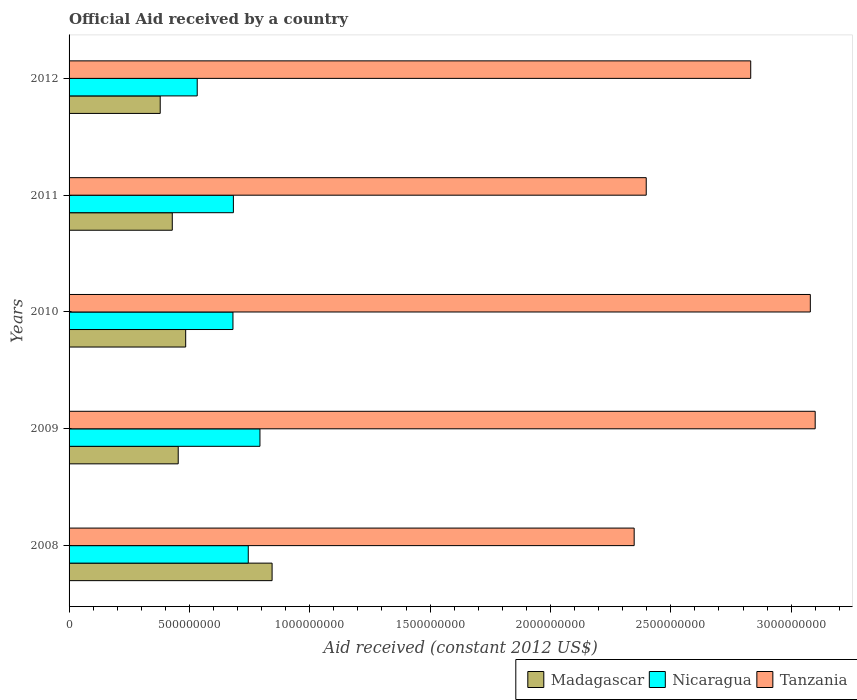How many groups of bars are there?
Your answer should be very brief. 5. Are the number of bars per tick equal to the number of legend labels?
Ensure brevity in your answer.  Yes. In how many cases, is the number of bars for a given year not equal to the number of legend labels?
Ensure brevity in your answer.  0. What is the net official aid received in Nicaragua in 2008?
Offer a very short reply. 7.44e+08. Across all years, what is the maximum net official aid received in Tanzania?
Make the answer very short. 3.10e+09. Across all years, what is the minimum net official aid received in Nicaragua?
Ensure brevity in your answer.  5.32e+08. In which year was the net official aid received in Madagascar minimum?
Keep it short and to the point. 2012. What is the total net official aid received in Madagascar in the graph?
Your answer should be very brief. 2.59e+09. What is the difference between the net official aid received in Tanzania in 2008 and that in 2010?
Give a very brief answer. -7.32e+08. What is the difference between the net official aid received in Nicaragua in 2009 and the net official aid received in Tanzania in 2012?
Ensure brevity in your answer.  -2.04e+09. What is the average net official aid received in Madagascar per year?
Your answer should be very brief. 5.18e+08. In the year 2011, what is the difference between the net official aid received in Madagascar and net official aid received in Tanzania?
Offer a very short reply. -1.97e+09. In how many years, is the net official aid received in Tanzania greater than 1000000000 US$?
Offer a very short reply. 5. What is the ratio of the net official aid received in Tanzania in 2009 to that in 2010?
Keep it short and to the point. 1.01. Is the difference between the net official aid received in Madagascar in 2008 and 2010 greater than the difference between the net official aid received in Tanzania in 2008 and 2010?
Ensure brevity in your answer.  Yes. What is the difference between the highest and the second highest net official aid received in Tanzania?
Give a very brief answer. 2.02e+07. What is the difference between the highest and the lowest net official aid received in Nicaragua?
Your response must be concise. 2.61e+08. What does the 1st bar from the top in 2009 represents?
Make the answer very short. Tanzania. What does the 3rd bar from the bottom in 2011 represents?
Ensure brevity in your answer.  Tanzania. Are all the bars in the graph horizontal?
Offer a terse response. Yes. How many years are there in the graph?
Your response must be concise. 5. What is the difference between two consecutive major ticks on the X-axis?
Make the answer very short. 5.00e+08. Are the values on the major ticks of X-axis written in scientific E-notation?
Your answer should be very brief. No. How many legend labels are there?
Make the answer very short. 3. What is the title of the graph?
Offer a terse response. Official Aid received by a country. What is the label or title of the X-axis?
Your answer should be compact. Aid received (constant 2012 US$). What is the Aid received (constant 2012 US$) of Madagascar in 2008?
Offer a terse response. 8.43e+08. What is the Aid received (constant 2012 US$) of Nicaragua in 2008?
Provide a succinct answer. 7.44e+08. What is the Aid received (constant 2012 US$) in Tanzania in 2008?
Make the answer very short. 2.35e+09. What is the Aid received (constant 2012 US$) of Madagascar in 2009?
Provide a succinct answer. 4.53e+08. What is the Aid received (constant 2012 US$) in Nicaragua in 2009?
Make the answer very short. 7.93e+08. What is the Aid received (constant 2012 US$) of Tanzania in 2009?
Your answer should be compact. 3.10e+09. What is the Aid received (constant 2012 US$) in Madagascar in 2010?
Your answer should be very brief. 4.85e+08. What is the Aid received (constant 2012 US$) in Nicaragua in 2010?
Give a very brief answer. 6.81e+08. What is the Aid received (constant 2012 US$) in Tanzania in 2010?
Your response must be concise. 3.08e+09. What is the Aid received (constant 2012 US$) of Madagascar in 2011?
Give a very brief answer. 4.29e+08. What is the Aid received (constant 2012 US$) of Nicaragua in 2011?
Ensure brevity in your answer.  6.83e+08. What is the Aid received (constant 2012 US$) of Tanzania in 2011?
Ensure brevity in your answer.  2.40e+09. What is the Aid received (constant 2012 US$) of Madagascar in 2012?
Provide a succinct answer. 3.79e+08. What is the Aid received (constant 2012 US$) of Nicaragua in 2012?
Provide a short and direct response. 5.32e+08. What is the Aid received (constant 2012 US$) in Tanzania in 2012?
Make the answer very short. 2.83e+09. Across all years, what is the maximum Aid received (constant 2012 US$) of Madagascar?
Provide a short and direct response. 8.43e+08. Across all years, what is the maximum Aid received (constant 2012 US$) in Nicaragua?
Ensure brevity in your answer.  7.93e+08. Across all years, what is the maximum Aid received (constant 2012 US$) of Tanzania?
Offer a very short reply. 3.10e+09. Across all years, what is the minimum Aid received (constant 2012 US$) in Madagascar?
Provide a succinct answer. 3.79e+08. Across all years, what is the minimum Aid received (constant 2012 US$) in Nicaragua?
Provide a succinct answer. 5.32e+08. Across all years, what is the minimum Aid received (constant 2012 US$) in Tanzania?
Make the answer very short. 2.35e+09. What is the total Aid received (constant 2012 US$) of Madagascar in the graph?
Your answer should be compact. 2.59e+09. What is the total Aid received (constant 2012 US$) in Nicaragua in the graph?
Ensure brevity in your answer.  3.43e+09. What is the total Aid received (constant 2012 US$) of Tanzania in the graph?
Your answer should be very brief. 1.38e+1. What is the difference between the Aid received (constant 2012 US$) in Madagascar in 2008 and that in 2009?
Your answer should be compact. 3.90e+08. What is the difference between the Aid received (constant 2012 US$) of Nicaragua in 2008 and that in 2009?
Your response must be concise. -4.85e+07. What is the difference between the Aid received (constant 2012 US$) of Tanzania in 2008 and that in 2009?
Offer a very short reply. -7.52e+08. What is the difference between the Aid received (constant 2012 US$) in Madagascar in 2008 and that in 2010?
Your answer should be compact. 3.59e+08. What is the difference between the Aid received (constant 2012 US$) in Nicaragua in 2008 and that in 2010?
Make the answer very short. 6.36e+07. What is the difference between the Aid received (constant 2012 US$) of Tanzania in 2008 and that in 2010?
Make the answer very short. -7.32e+08. What is the difference between the Aid received (constant 2012 US$) of Madagascar in 2008 and that in 2011?
Offer a very short reply. 4.15e+08. What is the difference between the Aid received (constant 2012 US$) of Nicaragua in 2008 and that in 2011?
Keep it short and to the point. 6.18e+07. What is the difference between the Aid received (constant 2012 US$) in Tanzania in 2008 and that in 2011?
Keep it short and to the point. -5.01e+07. What is the difference between the Aid received (constant 2012 US$) in Madagascar in 2008 and that in 2012?
Give a very brief answer. 4.65e+08. What is the difference between the Aid received (constant 2012 US$) of Nicaragua in 2008 and that in 2012?
Give a very brief answer. 2.12e+08. What is the difference between the Aid received (constant 2012 US$) in Tanzania in 2008 and that in 2012?
Your response must be concise. -4.84e+08. What is the difference between the Aid received (constant 2012 US$) of Madagascar in 2009 and that in 2010?
Offer a very short reply. -3.10e+07. What is the difference between the Aid received (constant 2012 US$) in Nicaragua in 2009 and that in 2010?
Keep it short and to the point. 1.12e+08. What is the difference between the Aid received (constant 2012 US$) in Tanzania in 2009 and that in 2010?
Give a very brief answer. 2.02e+07. What is the difference between the Aid received (constant 2012 US$) in Madagascar in 2009 and that in 2011?
Make the answer very short. 2.47e+07. What is the difference between the Aid received (constant 2012 US$) of Nicaragua in 2009 and that in 2011?
Provide a succinct answer. 1.10e+08. What is the difference between the Aid received (constant 2012 US$) in Tanzania in 2009 and that in 2011?
Your answer should be very brief. 7.02e+08. What is the difference between the Aid received (constant 2012 US$) in Madagascar in 2009 and that in 2012?
Make the answer very short. 7.48e+07. What is the difference between the Aid received (constant 2012 US$) of Nicaragua in 2009 and that in 2012?
Offer a very short reply. 2.61e+08. What is the difference between the Aid received (constant 2012 US$) in Tanzania in 2009 and that in 2012?
Offer a terse response. 2.68e+08. What is the difference between the Aid received (constant 2012 US$) in Madagascar in 2010 and that in 2011?
Offer a terse response. 5.57e+07. What is the difference between the Aid received (constant 2012 US$) in Nicaragua in 2010 and that in 2011?
Your answer should be very brief. -1.80e+06. What is the difference between the Aid received (constant 2012 US$) in Tanzania in 2010 and that in 2011?
Ensure brevity in your answer.  6.82e+08. What is the difference between the Aid received (constant 2012 US$) in Madagascar in 2010 and that in 2012?
Provide a succinct answer. 1.06e+08. What is the difference between the Aid received (constant 2012 US$) of Nicaragua in 2010 and that in 2012?
Ensure brevity in your answer.  1.48e+08. What is the difference between the Aid received (constant 2012 US$) in Tanzania in 2010 and that in 2012?
Give a very brief answer. 2.48e+08. What is the difference between the Aid received (constant 2012 US$) in Madagascar in 2011 and that in 2012?
Ensure brevity in your answer.  5.01e+07. What is the difference between the Aid received (constant 2012 US$) of Nicaragua in 2011 and that in 2012?
Your response must be concise. 1.50e+08. What is the difference between the Aid received (constant 2012 US$) of Tanzania in 2011 and that in 2012?
Offer a very short reply. -4.34e+08. What is the difference between the Aid received (constant 2012 US$) in Madagascar in 2008 and the Aid received (constant 2012 US$) in Nicaragua in 2009?
Provide a short and direct response. 5.04e+07. What is the difference between the Aid received (constant 2012 US$) of Madagascar in 2008 and the Aid received (constant 2012 US$) of Tanzania in 2009?
Provide a short and direct response. -2.26e+09. What is the difference between the Aid received (constant 2012 US$) of Nicaragua in 2008 and the Aid received (constant 2012 US$) of Tanzania in 2009?
Offer a terse response. -2.36e+09. What is the difference between the Aid received (constant 2012 US$) in Madagascar in 2008 and the Aid received (constant 2012 US$) in Nicaragua in 2010?
Ensure brevity in your answer.  1.63e+08. What is the difference between the Aid received (constant 2012 US$) in Madagascar in 2008 and the Aid received (constant 2012 US$) in Tanzania in 2010?
Your response must be concise. -2.24e+09. What is the difference between the Aid received (constant 2012 US$) of Nicaragua in 2008 and the Aid received (constant 2012 US$) of Tanzania in 2010?
Keep it short and to the point. -2.34e+09. What is the difference between the Aid received (constant 2012 US$) of Madagascar in 2008 and the Aid received (constant 2012 US$) of Nicaragua in 2011?
Offer a very short reply. 1.61e+08. What is the difference between the Aid received (constant 2012 US$) in Madagascar in 2008 and the Aid received (constant 2012 US$) in Tanzania in 2011?
Your response must be concise. -1.55e+09. What is the difference between the Aid received (constant 2012 US$) of Nicaragua in 2008 and the Aid received (constant 2012 US$) of Tanzania in 2011?
Make the answer very short. -1.65e+09. What is the difference between the Aid received (constant 2012 US$) in Madagascar in 2008 and the Aid received (constant 2012 US$) in Nicaragua in 2012?
Keep it short and to the point. 3.11e+08. What is the difference between the Aid received (constant 2012 US$) of Madagascar in 2008 and the Aid received (constant 2012 US$) of Tanzania in 2012?
Give a very brief answer. -1.99e+09. What is the difference between the Aid received (constant 2012 US$) in Nicaragua in 2008 and the Aid received (constant 2012 US$) in Tanzania in 2012?
Your answer should be very brief. -2.09e+09. What is the difference between the Aid received (constant 2012 US$) of Madagascar in 2009 and the Aid received (constant 2012 US$) of Nicaragua in 2010?
Give a very brief answer. -2.27e+08. What is the difference between the Aid received (constant 2012 US$) of Madagascar in 2009 and the Aid received (constant 2012 US$) of Tanzania in 2010?
Give a very brief answer. -2.63e+09. What is the difference between the Aid received (constant 2012 US$) of Nicaragua in 2009 and the Aid received (constant 2012 US$) of Tanzania in 2010?
Your answer should be very brief. -2.29e+09. What is the difference between the Aid received (constant 2012 US$) in Madagascar in 2009 and the Aid received (constant 2012 US$) in Nicaragua in 2011?
Your answer should be compact. -2.29e+08. What is the difference between the Aid received (constant 2012 US$) of Madagascar in 2009 and the Aid received (constant 2012 US$) of Tanzania in 2011?
Your answer should be compact. -1.94e+09. What is the difference between the Aid received (constant 2012 US$) of Nicaragua in 2009 and the Aid received (constant 2012 US$) of Tanzania in 2011?
Offer a terse response. -1.60e+09. What is the difference between the Aid received (constant 2012 US$) in Madagascar in 2009 and the Aid received (constant 2012 US$) in Nicaragua in 2012?
Your response must be concise. -7.89e+07. What is the difference between the Aid received (constant 2012 US$) of Madagascar in 2009 and the Aid received (constant 2012 US$) of Tanzania in 2012?
Give a very brief answer. -2.38e+09. What is the difference between the Aid received (constant 2012 US$) of Nicaragua in 2009 and the Aid received (constant 2012 US$) of Tanzania in 2012?
Your answer should be compact. -2.04e+09. What is the difference between the Aid received (constant 2012 US$) of Madagascar in 2010 and the Aid received (constant 2012 US$) of Nicaragua in 2011?
Your response must be concise. -1.98e+08. What is the difference between the Aid received (constant 2012 US$) in Madagascar in 2010 and the Aid received (constant 2012 US$) in Tanzania in 2011?
Your answer should be compact. -1.91e+09. What is the difference between the Aid received (constant 2012 US$) of Nicaragua in 2010 and the Aid received (constant 2012 US$) of Tanzania in 2011?
Your response must be concise. -1.72e+09. What is the difference between the Aid received (constant 2012 US$) of Madagascar in 2010 and the Aid received (constant 2012 US$) of Nicaragua in 2012?
Keep it short and to the point. -4.79e+07. What is the difference between the Aid received (constant 2012 US$) of Madagascar in 2010 and the Aid received (constant 2012 US$) of Tanzania in 2012?
Your answer should be compact. -2.35e+09. What is the difference between the Aid received (constant 2012 US$) of Nicaragua in 2010 and the Aid received (constant 2012 US$) of Tanzania in 2012?
Keep it short and to the point. -2.15e+09. What is the difference between the Aid received (constant 2012 US$) of Madagascar in 2011 and the Aid received (constant 2012 US$) of Nicaragua in 2012?
Your answer should be compact. -1.04e+08. What is the difference between the Aid received (constant 2012 US$) of Madagascar in 2011 and the Aid received (constant 2012 US$) of Tanzania in 2012?
Your response must be concise. -2.40e+09. What is the difference between the Aid received (constant 2012 US$) in Nicaragua in 2011 and the Aid received (constant 2012 US$) in Tanzania in 2012?
Your response must be concise. -2.15e+09. What is the average Aid received (constant 2012 US$) in Madagascar per year?
Your response must be concise. 5.18e+08. What is the average Aid received (constant 2012 US$) of Nicaragua per year?
Keep it short and to the point. 6.87e+08. What is the average Aid received (constant 2012 US$) of Tanzania per year?
Keep it short and to the point. 2.75e+09. In the year 2008, what is the difference between the Aid received (constant 2012 US$) in Madagascar and Aid received (constant 2012 US$) in Nicaragua?
Ensure brevity in your answer.  9.90e+07. In the year 2008, what is the difference between the Aid received (constant 2012 US$) in Madagascar and Aid received (constant 2012 US$) in Tanzania?
Your answer should be very brief. -1.50e+09. In the year 2008, what is the difference between the Aid received (constant 2012 US$) in Nicaragua and Aid received (constant 2012 US$) in Tanzania?
Ensure brevity in your answer.  -1.60e+09. In the year 2009, what is the difference between the Aid received (constant 2012 US$) in Madagascar and Aid received (constant 2012 US$) in Nicaragua?
Offer a very short reply. -3.40e+08. In the year 2009, what is the difference between the Aid received (constant 2012 US$) of Madagascar and Aid received (constant 2012 US$) of Tanzania?
Offer a terse response. -2.65e+09. In the year 2009, what is the difference between the Aid received (constant 2012 US$) in Nicaragua and Aid received (constant 2012 US$) in Tanzania?
Your response must be concise. -2.31e+09. In the year 2010, what is the difference between the Aid received (constant 2012 US$) of Madagascar and Aid received (constant 2012 US$) of Nicaragua?
Your answer should be very brief. -1.96e+08. In the year 2010, what is the difference between the Aid received (constant 2012 US$) of Madagascar and Aid received (constant 2012 US$) of Tanzania?
Give a very brief answer. -2.59e+09. In the year 2010, what is the difference between the Aid received (constant 2012 US$) of Nicaragua and Aid received (constant 2012 US$) of Tanzania?
Give a very brief answer. -2.40e+09. In the year 2011, what is the difference between the Aid received (constant 2012 US$) of Madagascar and Aid received (constant 2012 US$) of Nicaragua?
Provide a short and direct response. -2.54e+08. In the year 2011, what is the difference between the Aid received (constant 2012 US$) in Madagascar and Aid received (constant 2012 US$) in Tanzania?
Offer a terse response. -1.97e+09. In the year 2011, what is the difference between the Aid received (constant 2012 US$) in Nicaragua and Aid received (constant 2012 US$) in Tanzania?
Your response must be concise. -1.72e+09. In the year 2012, what is the difference between the Aid received (constant 2012 US$) of Madagascar and Aid received (constant 2012 US$) of Nicaragua?
Your response must be concise. -1.54e+08. In the year 2012, what is the difference between the Aid received (constant 2012 US$) in Madagascar and Aid received (constant 2012 US$) in Tanzania?
Provide a short and direct response. -2.45e+09. In the year 2012, what is the difference between the Aid received (constant 2012 US$) in Nicaragua and Aid received (constant 2012 US$) in Tanzania?
Your answer should be compact. -2.30e+09. What is the ratio of the Aid received (constant 2012 US$) of Madagascar in 2008 to that in 2009?
Your answer should be compact. 1.86. What is the ratio of the Aid received (constant 2012 US$) in Nicaragua in 2008 to that in 2009?
Make the answer very short. 0.94. What is the ratio of the Aid received (constant 2012 US$) in Tanzania in 2008 to that in 2009?
Offer a very short reply. 0.76. What is the ratio of the Aid received (constant 2012 US$) of Madagascar in 2008 to that in 2010?
Your answer should be very brief. 1.74. What is the ratio of the Aid received (constant 2012 US$) in Nicaragua in 2008 to that in 2010?
Keep it short and to the point. 1.09. What is the ratio of the Aid received (constant 2012 US$) of Tanzania in 2008 to that in 2010?
Your response must be concise. 0.76. What is the ratio of the Aid received (constant 2012 US$) of Madagascar in 2008 to that in 2011?
Your response must be concise. 1.97. What is the ratio of the Aid received (constant 2012 US$) in Nicaragua in 2008 to that in 2011?
Ensure brevity in your answer.  1.09. What is the ratio of the Aid received (constant 2012 US$) in Tanzania in 2008 to that in 2011?
Your answer should be compact. 0.98. What is the ratio of the Aid received (constant 2012 US$) of Madagascar in 2008 to that in 2012?
Your answer should be very brief. 2.23. What is the ratio of the Aid received (constant 2012 US$) of Nicaragua in 2008 to that in 2012?
Your answer should be very brief. 1.4. What is the ratio of the Aid received (constant 2012 US$) in Tanzania in 2008 to that in 2012?
Provide a short and direct response. 0.83. What is the ratio of the Aid received (constant 2012 US$) in Madagascar in 2009 to that in 2010?
Keep it short and to the point. 0.94. What is the ratio of the Aid received (constant 2012 US$) of Nicaragua in 2009 to that in 2010?
Provide a succinct answer. 1.16. What is the ratio of the Aid received (constant 2012 US$) in Tanzania in 2009 to that in 2010?
Your response must be concise. 1.01. What is the ratio of the Aid received (constant 2012 US$) of Madagascar in 2009 to that in 2011?
Keep it short and to the point. 1.06. What is the ratio of the Aid received (constant 2012 US$) in Nicaragua in 2009 to that in 2011?
Offer a terse response. 1.16. What is the ratio of the Aid received (constant 2012 US$) in Tanzania in 2009 to that in 2011?
Make the answer very short. 1.29. What is the ratio of the Aid received (constant 2012 US$) in Madagascar in 2009 to that in 2012?
Ensure brevity in your answer.  1.2. What is the ratio of the Aid received (constant 2012 US$) of Nicaragua in 2009 to that in 2012?
Your answer should be very brief. 1.49. What is the ratio of the Aid received (constant 2012 US$) of Tanzania in 2009 to that in 2012?
Ensure brevity in your answer.  1.09. What is the ratio of the Aid received (constant 2012 US$) in Madagascar in 2010 to that in 2011?
Offer a terse response. 1.13. What is the ratio of the Aid received (constant 2012 US$) in Nicaragua in 2010 to that in 2011?
Your answer should be compact. 1. What is the ratio of the Aid received (constant 2012 US$) in Tanzania in 2010 to that in 2011?
Make the answer very short. 1.28. What is the ratio of the Aid received (constant 2012 US$) in Madagascar in 2010 to that in 2012?
Provide a short and direct response. 1.28. What is the ratio of the Aid received (constant 2012 US$) of Nicaragua in 2010 to that in 2012?
Offer a terse response. 1.28. What is the ratio of the Aid received (constant 2012 US$) of Tanzania in 2010 to that in 2012?
Provide a succinct answer. 1.09. What is the ratio of the Aid received (constant 2012 US$) in Madagascar in 2011 to that in 2012?
Make the answer very short. 1.13. What is the ratio of the Aid received (constant 2012 US$) in Nicaragua in 2011 to that in 2012?
Your response must be concise. 1.28. What is the ratio of the Aid received (constant 2012 US$) of Tanzania in 2011 to that in 2012?
Give a very brief answer. 0.85. What is the difference between the highest and the second highest Aid received (constant 2012 US$) in Madagascar?
Give a very brief answer. 3.59e+08. What is the difference between the highest and the second highest Aid received (constant 2012 US$) in Nicaragua?
Provide a short and direct response. 4.85e+07. What is the difference between the highest and the second highest Aid received (constant 2012 US$) of Tanzania?
Your response must be concise. 2.02e+07. What is the difference between the highest and the lowest Aid received (constant 2012 US$) in Madagascar?
Your answer should be very brief. 4.65e+08. What is the difference between the highest and the lowest Aid received (constant 2012 US$) of Nicaragua?
Provide a succinct answer. 2.61e+08. What is the difference between the highest and the lowest Aid received (constant 2012 US$) in Tanzania?
Provide a short and direct response. 7.52e+08. 